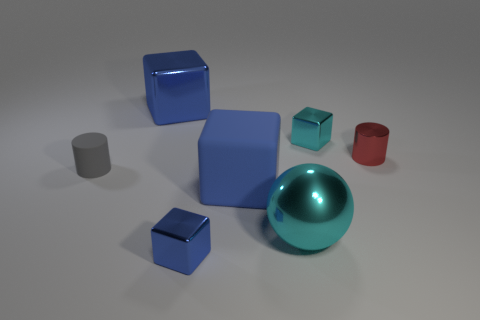Subtract all blue blocks. How many were subtracted if there are1blue blocks left? 2 Subtract all cyan blocks. How many blocks are left? 3 Add 1 blue rubber spheres. How many objects exist? 8 Subtract 3 cubes. How many cubes are left? 1 Subtract all red cylinders. How many blue blocks are left? 3 Subtract all cylinders. How many objects are left? 5 Subtract all blue blocks. How many blocks are left? 1 Add 3 large blue rubber cubes. How many large blue rubber cubes are left? 4 Add 1 cyan spheres. How many cyan spheres exist? 2 Subtract 0 brown cylinders. How many objects are left? 7 